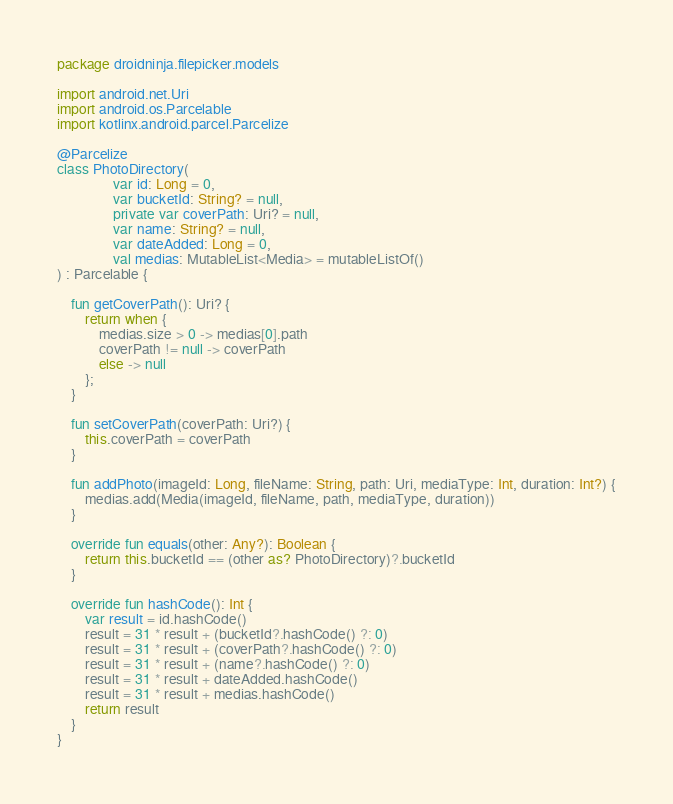Convert code to text. <code><loc_0><loc_0><loc_500><loc_500><_Kotlin_>package droidninja.filepicker.models

import android.net.Uri
import android.os.Parcelable
import kotlinx.android.parcel.Parcelize

@Parcelize
class PhotoDirectory(
                var id: Long = 0,
                var bucketId: String? = null,
                private var coverPath: Uri? = null,
                var name: String? = null,
                var dateAdded: Long = 0,
                val medias: MutableList<Media> = mutableListOf()
) : Parcelable {

    fun getCoverPath(): Uri? {
        return when {
            medias.size > 0 -> medias[0].path
            coverPath != null -> coverPath
            else -> null
        };
    }

    fun setCoverPath(coverPath: Uri?) {
        this.coverPath = coverPath
    }

    fun addPhoto(imageId: Long, fileName: String, path: Uri, mediaType: Int, duration: Int?) {
        medias.add(Media(imageId, fileName, path, mediaType, duration))
    }

    override fun equals(other: Any?): Boolean {
        return this.bucketId == (other as? PhotoDirectory)?.bucketId
    }

    override fun hashCode(): Int {
        var result = id.hashCode()
        result = 31 * result + (bucketId?.hashCode() ?: 0)
        result = 31 * result + (coverPath?.hashCode() ?: 0)
        result = 31 * result + (name?.hashCode() ?: 0)
        result = 31 * result + dateAdded.hashCode()
        result = 31 * result + medias.hashCode()
        return result
    }
}</code> 